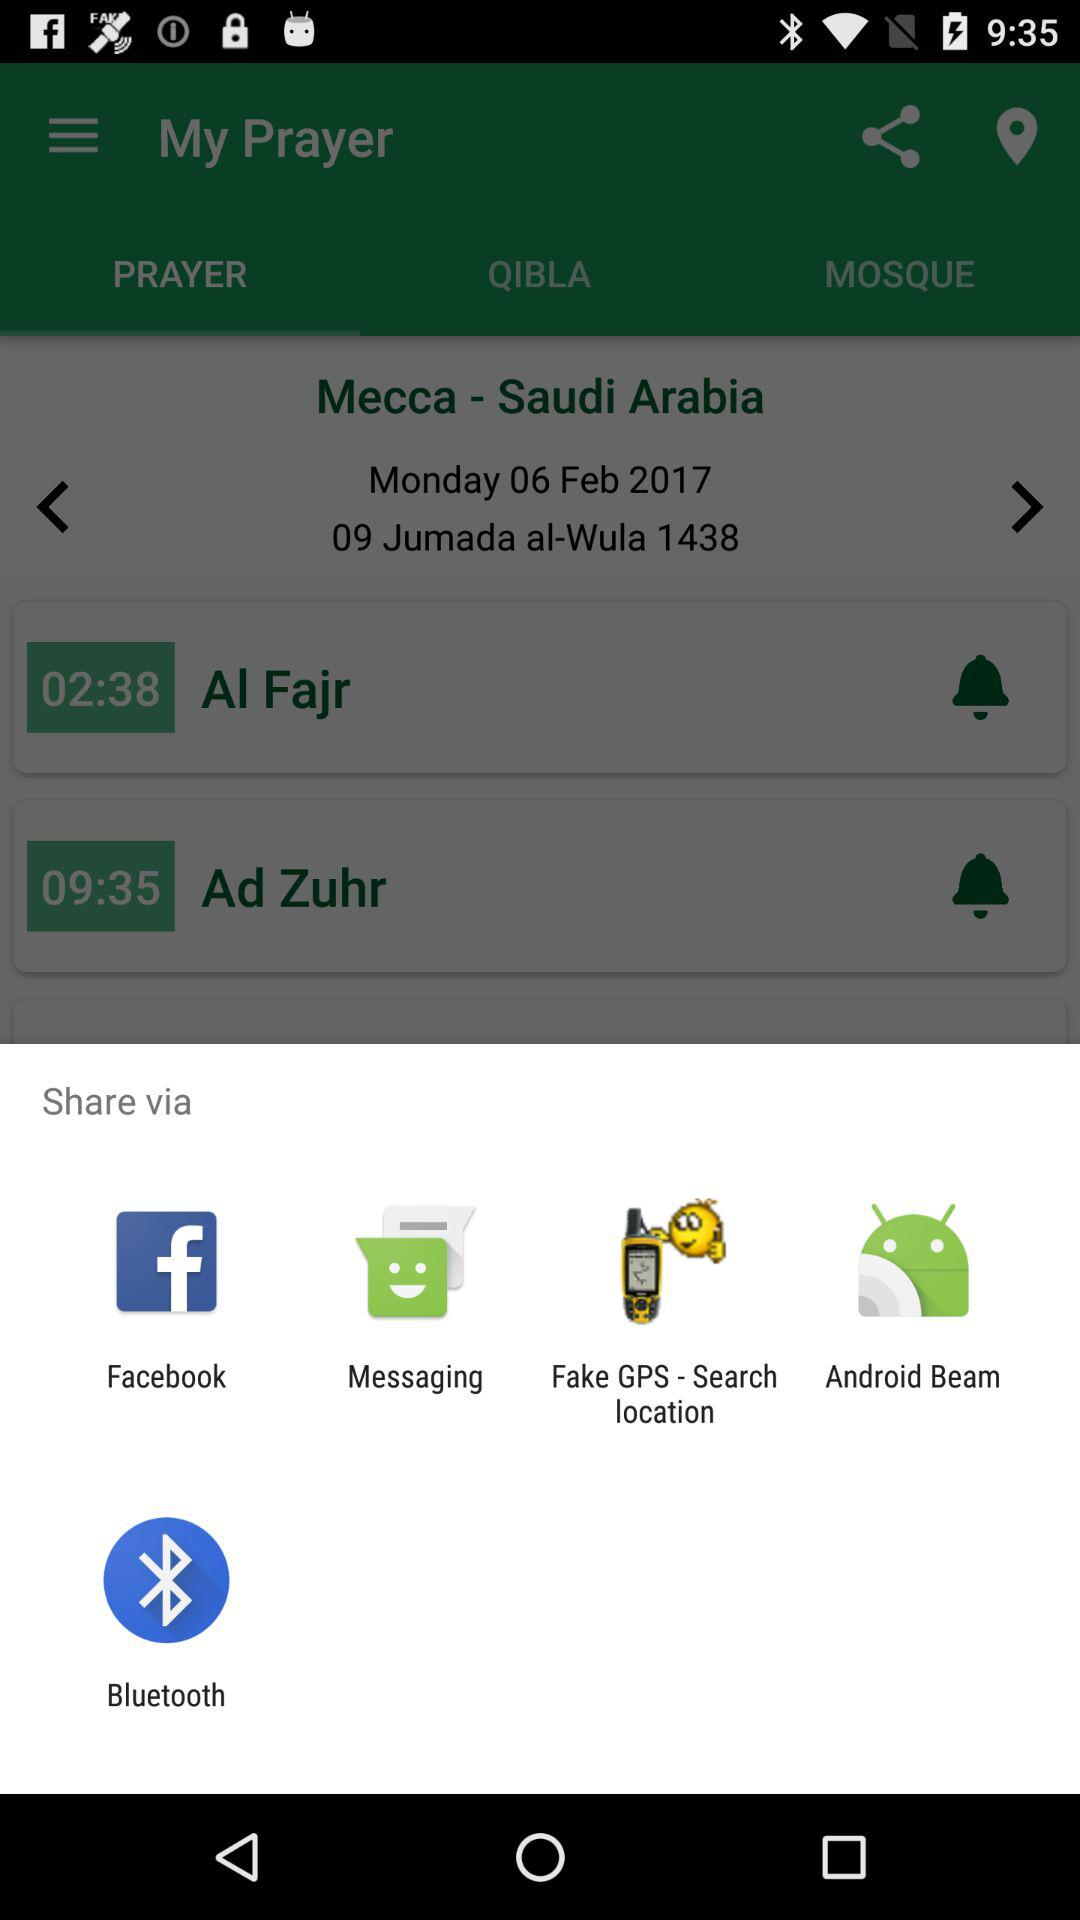How many prayers are there?
Answer the question using a single word or phrase. 2 